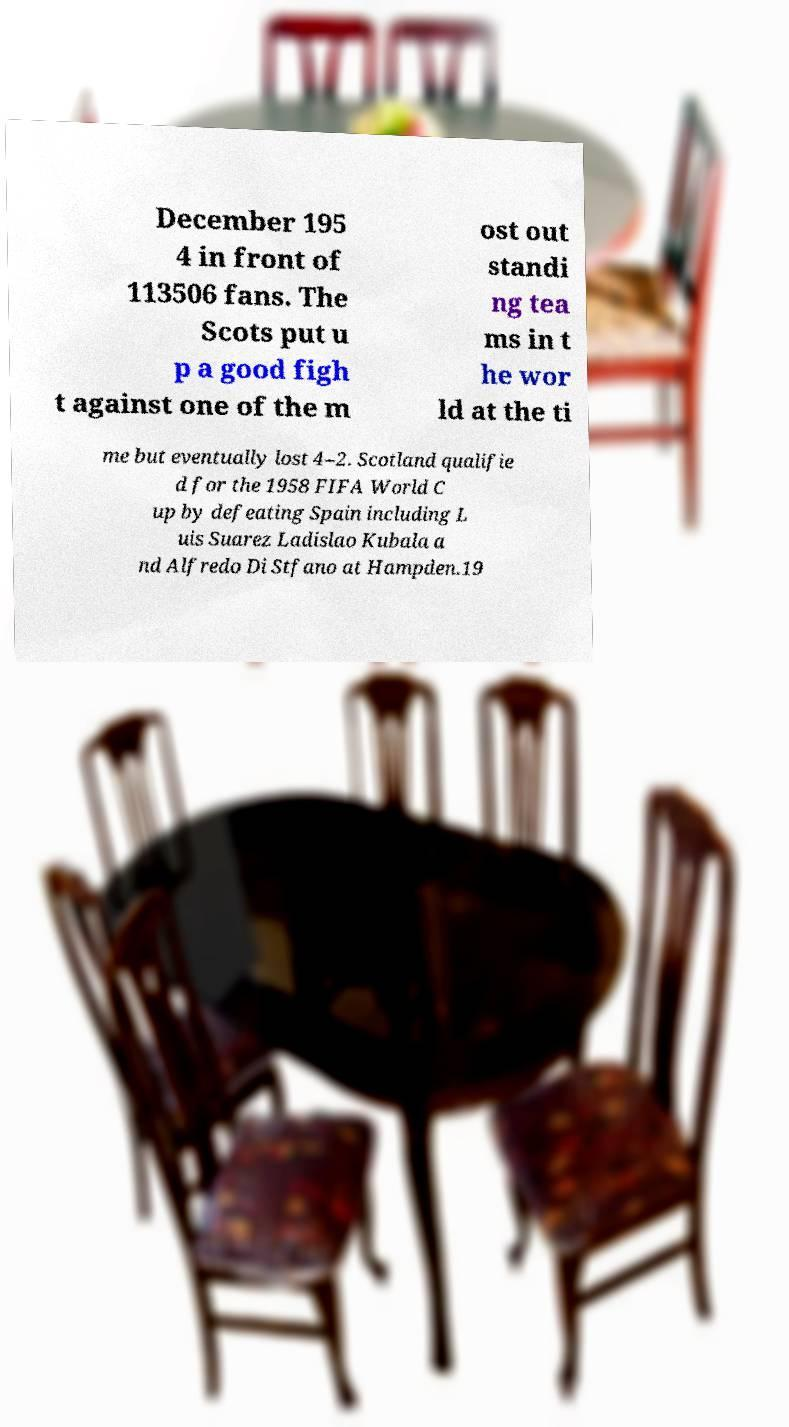For documentation purposes, I need the text within this image transcribed. Could you provide that? December 195 4 in front of 113506 fans. The Scots put u p a good figh t against one of the m ost out standi ng tea ms in t he wor ld at the ti me but eventually lost 4–2. Scotland qualifie d for the 1958 FIFA World C up by defeating Spain including L uis Suarez Ladislao Kubala a nd Alfredo Di Stfano at Hampden.19 